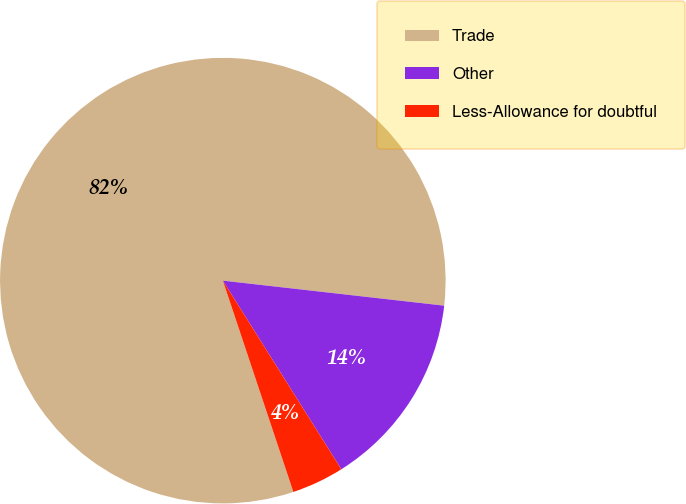Convert chart to OTSL. <chart><loc_0><loc_0><loc_500><loc_500><pie_chart><fcel>Trade<fcel>Other<fcel>Less-Allowance for doubtful<nl><fcel>81.92%<fcel>14.28%<fcel>3.8%<nl></chart> 